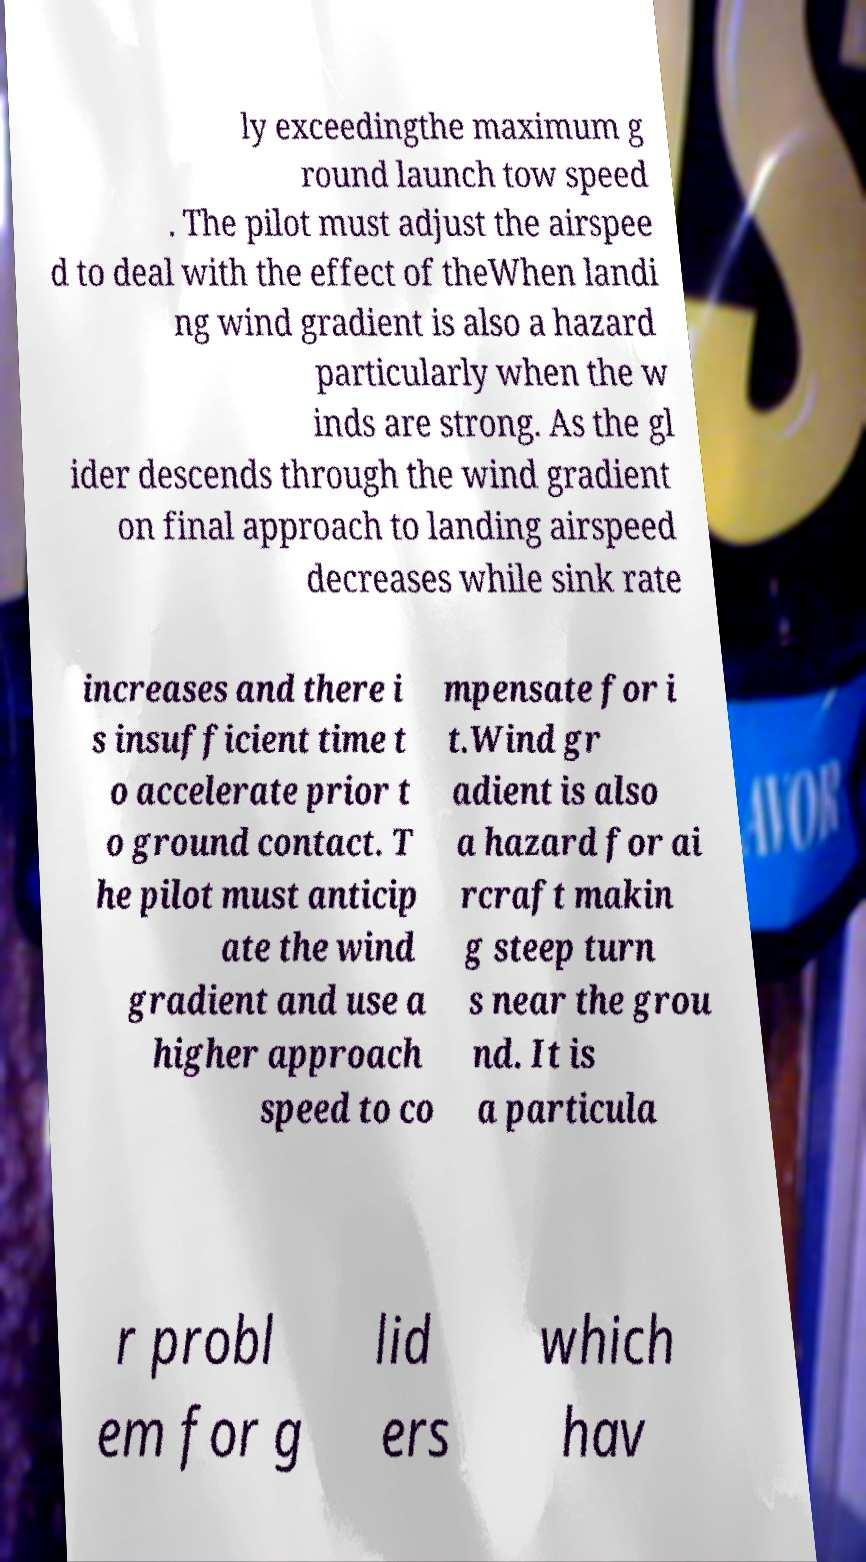Can you accurately transcribe the text from the provided image for me? ly exceedingthe maximum g round launch tow speed . The pilot must adjust the airspee d to deal with the effect of theWhen landi ng wind gradient is also a hazard particularly when the w inds are strong. As the gl ider descends through the wind gradient on final approach to landing airspeed decreases while sink rate increases and there i s insufficient time t o accelerate prior t o ground contact. T he pilot must anticip ate the wind gradient and use a higher approach speed to co mpensate for i t.Wind gr adient is also a hazard for ai rcraft makin g steep turn s near the grou nd. It is a particula r probl em for g lid ers which hav 